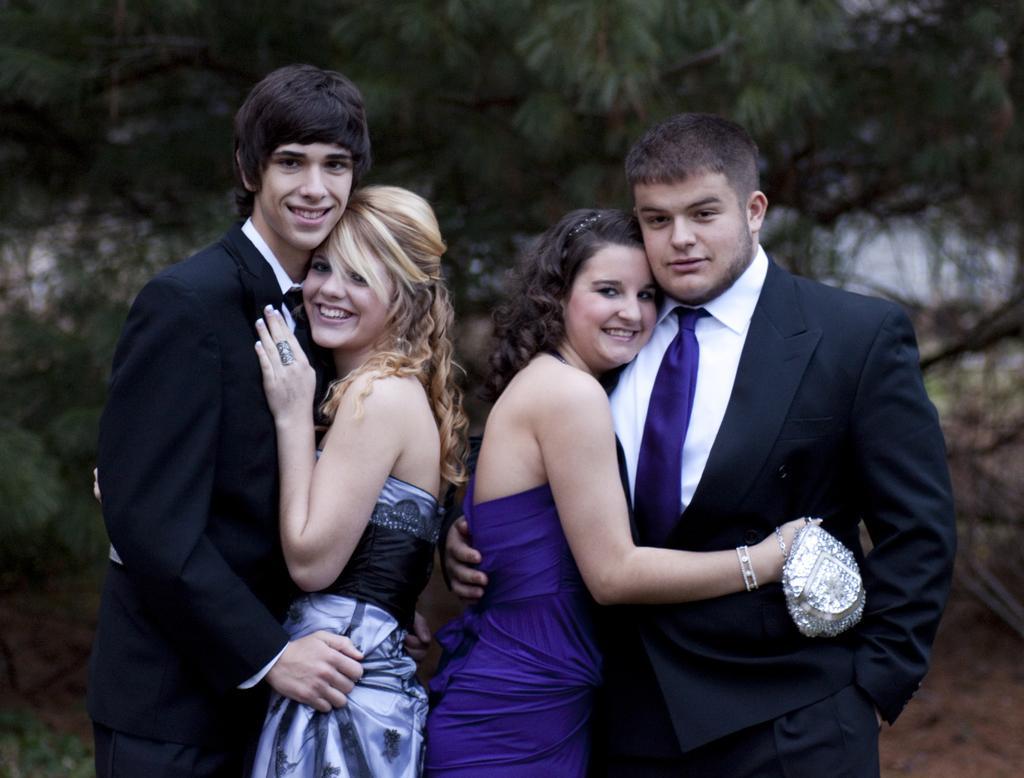How would you summarize this image in a sentence or two? In this image I can see four persons standing, the person at right is wearing black blazer, white shirt and blue color tie and the person at left is wearing black blazer, white color shirt. In front the two persons are wearing blue, gray and white color dress, background I can see trees in green color. 